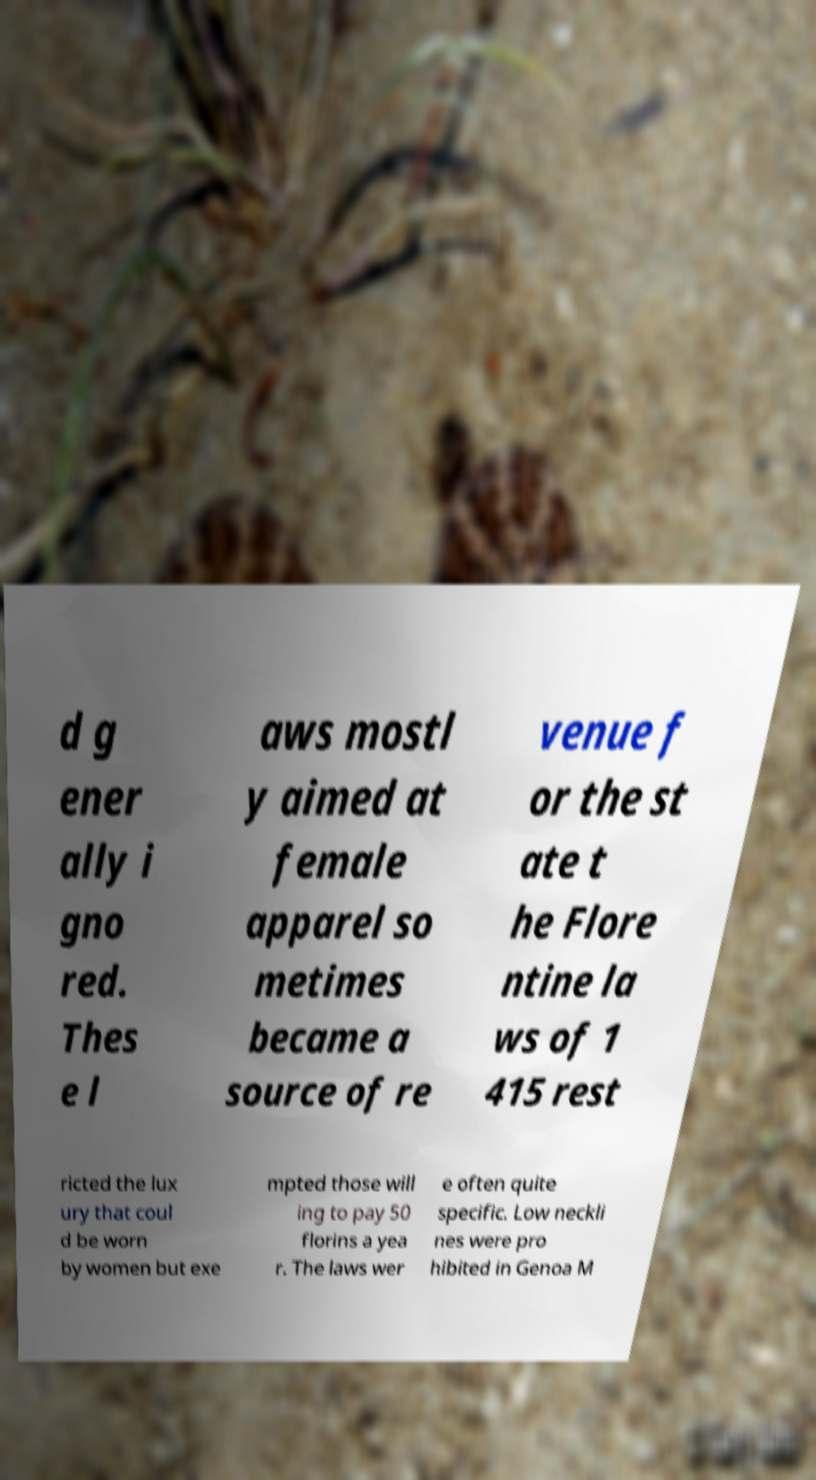Please read and relay the text visible in this image. What does it say? d g ener ally i gno red. Thes e l aws mostl y aimed at female apparel so metimes became a source of re venue f or the st ate t he Flore ntine la ws of 1 415 rest ricted the lux ury that coul d be worn by women but exe mpted those will ing to pay 50 florins a yea r. The laws wer e often quite specific. Low neckli nes were pro hibited in Genoa M 